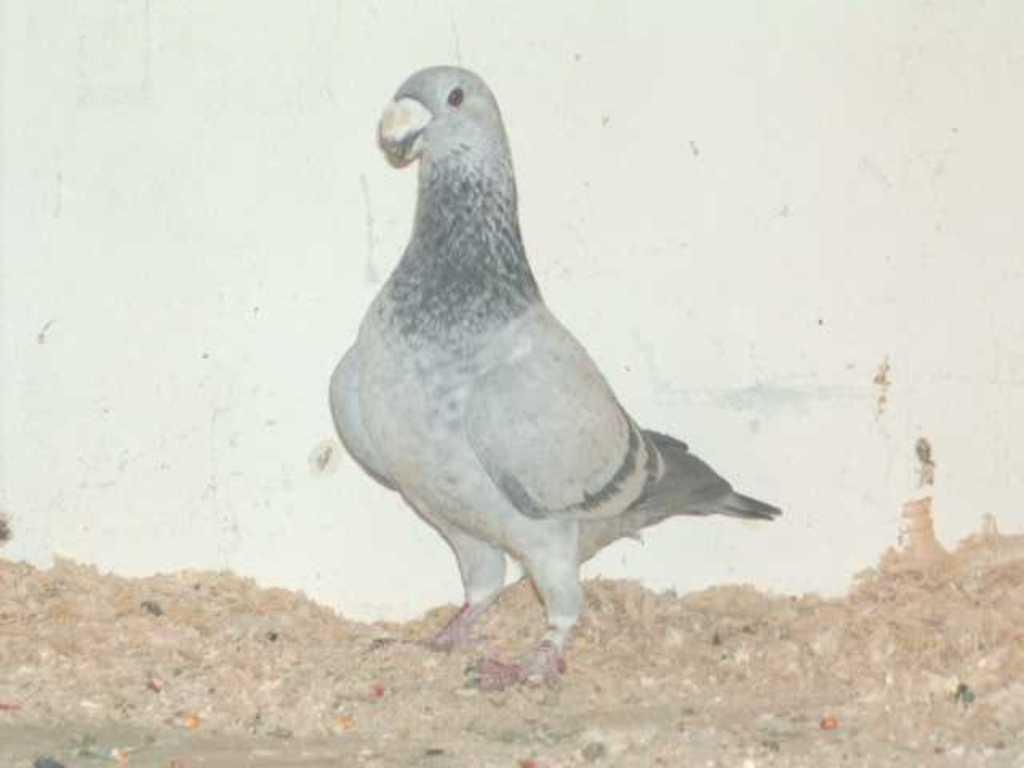What type of animal is in the image? There is a pigeon in the image. What type of terrain is visible in the image? There is sand in the image. What type of structure is in the image? There is a wall in the image. What type of apparel is the pigeon wearing in the image? Pigeons do not wear apparel, so there is no clothing visible on the pigeon in the image. 